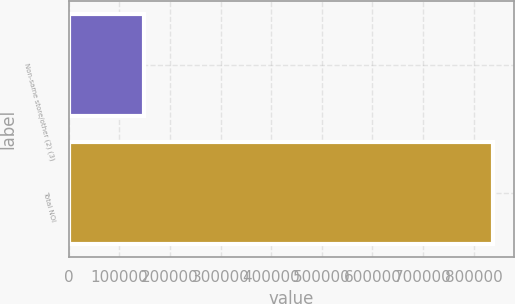<chart> <loc_0><loc_0><loc_500><loc_500><bar_chart><fcel>Non-same store/other (2) (3)<fcel>Total NOI<nl><fcel>148560<fcel>838299<nl></chart> 